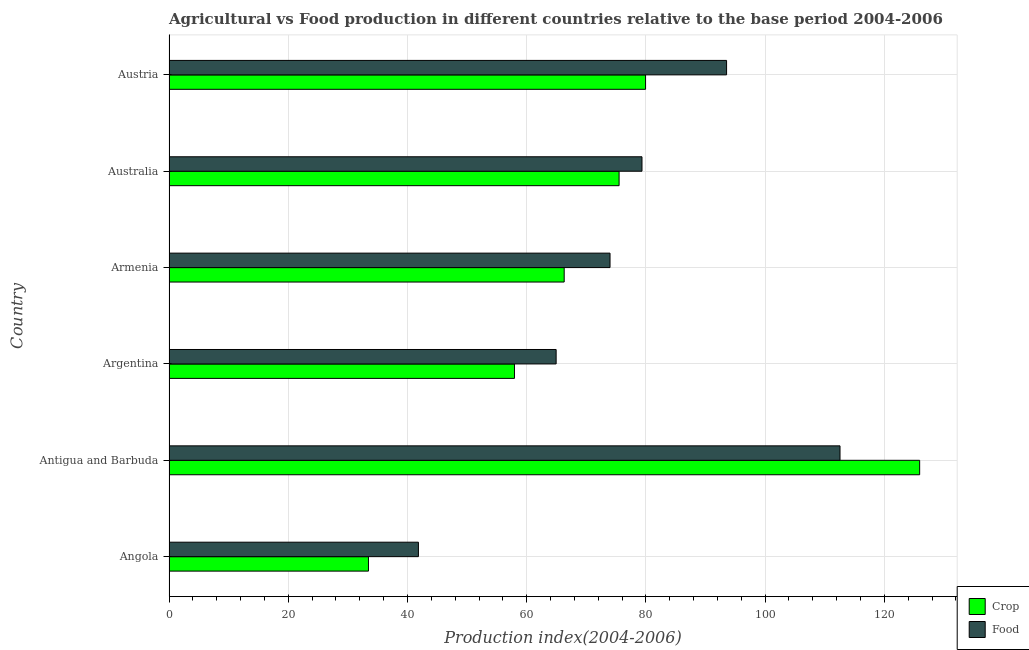Are the number of bars per tick equal to the number of legend labels?
Make the answer very short. Yes. Are the number of bars on each tick of the Y-axis equal?
Give a very brief answer. Yes. What is the label of the 6th group of bars from the top?
Provide a succinct answer. Angola. In how many cases, is the number of bars for a given country not equal to the number of legend labels?
Offer a very short reply. 0. What is the food production index in Austria?
Provide a short and direct response. 93.53. Across all countries, what is the maximum crop production index?
Provide a succinct answer. 125.92. Across all countries, what is the minimum food production index?
Provide a short and direct response. 41.84. In which country was the crop production index maximum?
Keep it short and to the point. Antigua and Barbuda. In which country was the crop production index minimum?
Provide a succinct answer. Angola. What is the total food production index in the graph?
Keep it short and to the point. 466.19. What is the difference between the crop production index in Angola and that in Argentina?
Keep it short and to the point. -24.49. What is the difference between the crop production index in Argentina and the food production index in Armenia?
Give a very brief answer. -16.03. What is the average crop production index per country?
Make the answer very short. 73.18. What is the difference between the crop production index and food production index in Armenia?
Make the answer very short. -7.69. What is the ratio of the food production index in Antigua and Barbuda to that in Austria?
Your answer should be very brief. 1.2. Is the food production index in Armenia less than that in Austria?
Keep it short and to the point. Yes. What is the difference between the highest and the second highest food production index?
Offer a very short reply. 19.03. What is the difference between the highest and the lowest crop production index?
Ensure brevity in your answer.  92.46. In how many countries, is the food production index greater than the average food production index taken over all countries?
Keep it short and to the point. 3. Is the sum of the crop production index in Argentina and Armenia greater than the maximum food production index across all countries?
Offer a terse response. Yes. What does the 2nd bar from the top in Australia represents?
Provide a succinct answer. Crop. What does the 1st bar from the bottom in Argentina represents?
Ensure brevity in your answer.  Crop. Are all the bars in the graph horizontal?
Your answer should be compact. Yes. What is the difference between two consecutive major ticks on the X-axis?
Make the answer very short. 20. Where does the legend appear in the graph?
Your answer should be compact. Bottom right. What is the title of the graph?
Offer a very short reply. Agricultural vs Food production in different countries relative to the base period 2004-2006. What is the label or title of the X-axis?
Your answer should be compact. Production index(2004-2006). What is the label or title of the Y-axis?
Offer a very short reply. Country. What is the Production index(2004-2006) of Crop in Angola?
Your answer should be very brief. 33.46. What is the Production index(2004-2006) in Food in Angola?
Ensure brevity in your answer.  41.84. What is the Production index(2004-2006) in Crop in Antigua and Barbuda?
Your response must be concise. 125.92. What is the Production index(2004-2006) of Food in Antigua and Barbuda?
Offer a very short reply. 112.56. What is the Production index(2004-2006) in Crop in Argentina?
Offer a very short reply. 57.95. What is the Production index(2004-2006) in Food in Argentina?
Offer a very short reply. 64.94. What is the Production index(2004-2006) of Crop in Armenia?
Your answer should be very brief. 66.29. What is the Production index(2004-2006) in Food in Armenia?
Your response must be concise. 73.98. What is the Production index(2004-2006) in Crop in Australia?
Make the answer very short. 75.5. What is the Production index(2004-2006) of Food in Australia?
Ensure brevity in your answer.  79.34. What is the Production index(2004-2006) of Crop in Austria?
Your answer should be compact. 79.94. What is the Production index(2004-2006) in Food in Austria?
Provide a short and direct response. 93.53. Across all countries, what is the maximum Production index(2004-2006) of Crop?
Your answer should be compact. 125.92. Across all countries, what is the maximum Production index(2004-2006) of Food?
Keep it short and to the point. 112.56. Across all countries, what is the minimum Production index(2004-2006) in Crop?
Keep it short and to the point. 33.46. Across all countries, what is the minimum Production index(2004-2006) of Food?
Your response must be concise. 41.84. What is the total Production index(2004-2006) of Crop in the graph?
Your response must be concise. 439.06. What is the total Production index(2004-2006) of Food in the graph?
Keep it short and to the point. 466.19. What is the difference between the Production index(2004-2006) of Crop in Angola and that in Antigua and Barbuda?
Give a very brief answer. -92.46. What is the difference between the Production index(2004-2006) in Food in Angola and that in Antigua and Barbuda?
Give a very brief answer. -70.72. What is the difference between the Production index(2004-2006) of Crop in Angola and that in Argentina?
Your response must be concise. -24.49. What is the difference between the Production index(2004-2006) in Food in Angola and that in Argentina?
Give a very brief answer. -23.1. What is the difference between the Production index(2004-2006) in Crop in Angola and that in Armenia?
Your response must be concise. -32.83. What is the difference between the Production index(2004-2006) in Food in Angola and that in Armenia?
Offer a very short reply. -32.14. What is the difference between the Production index(2004-2006) of Crop in Angola and that in Australia?
Your answer should be very brief. -42.04. What is the difference between the Production index(2004-2006) of Food in Angola and that in Australia?
Your response must be concise. -37.5. What is the difference between the Production index(2004-2006) of Crop in Angola and that in Austria?
Keep it short and to the point. -46.48. What is the difference between the Production index(2004-2006) in Food in Angola and that in Austria?
Make the answer very short. -51.69. What is the difference between the Production index(2004-2006) of Crop in Antigua and Barbuda and that in Argentina?
Offer a terse response. 67.97. What is the difference between the Production index(2004-2006) of Food in Antigua and Barbuda and that in Argentina?
Give a very brief answer. 47.62. What is the difference between the Production index(2004-2006) of Crop in Antigua and Barbuda and that in Armenia?
Make the answer very short. 59.63. What is the difference between the Production index(2004-2006) in Food in Antigua and Barbuda and that in Armenia?
Ensure brevity in your answer.  38.58. What is the difference between the Production index(2004-2006) of Crop in Antigua and Barbuda and that in Australia?
Make the answer very short. 50.42. What is the difference between the Production index(2004-2006) in Food in Antigua and Barbuda and that in Australia?
Your answer should be compact. 33.22. What is the difference between the Production index(2004-2006) in Crop in Antigua and Barbuda and that in Austria?
Your response must be concise. 45.98. What is the difference between the Production index(2004-2006) of Food in Antigua and Barbuda and that in Austria?
Offer a terse response. 19.03. What is the difference between the Production index(2004-2006) of Crop in Argentina and that in Armenia?
Keep it short and to the point. -8.34. What is the difference between the Production index(2004-2006) in Food in Argentina and that in Armenia?
Keep it short and to the point. -9.04. What is the difference between the Production index(2004-2006) in Crop in Argentina and that in Australia?
Offer a terse response. -17.55. What is the difference between the Production index(2004-2006) of Food in Argentina and that in Australia?
Keep it short and to the point. -14.4. What is the difference between the Production index(2004-2006) in Crop in Argentina and that in Austria?
Your answer should be very brief. -21.99. What is the difference between the Production index(2004-2006) in Food in Argentina and that in Austria?
Provide a short and direct response. -28.59. What is the difference between the Production index(2004-2006) of Crop in Armenia and that in Australia?
Your answer should be compact. -9.21. What is the difference between the Production index(2004-2006) of Food in Armenia and that in Australia?
Offer a terse response. -5.36. What is the difference between the Production index(2004-2006) in Crop in Armenia and that in Austria?
Offer a very short reply. -13.65. What is the difference between the Production index(2004-2006) of Food in Armenia and that in Austria?
Your answer should be very brief. -19.55. What is the difference between the Production index(2004-2006) of Crop in Australia and that in Austria?
Give a very brief answer. -4.44. What is the difference between the Production index(2004-2006) of Food in Australia and that in Austria?
Offer a very short reply. -14.19. What is the difference between the Production index(2004-2006) in Crop in Angola and the Production index(2004-2006) in Food in Antigua and Barbuda?
Make the answer very short. -79.1. What is the difference between the Production index(2004-2006) of Crop in Angola and the Production index(2004-2006) of Food in Argentina?
Your answer should be compact. -31.48. What is the difference between the Production index(2004-2006) of Crop in Angola and the Production index(2004-2006) of Food in Armenia?
Your answer should be compact. -40.52. What is the difference between the Production index(2004-2006) of Crop in Angola and the Production index(2004-2006) of Food in Australia?
Make the answer very short. -45.88. What is the difference between the Production index(2004-2006) in Crop in Angola and the Production index(2004-2006) in Food in Austria?
Your answer should be compact. -60.07. What is the difference between the Production index(2004-2006) in Crop in Antigua and Barbuda and the Production index(2004-2006) in Food in Argentina?
Ensure brevity in your answer.  60.98. What is the difference between the Production index(2004-2006) of Crop in Antigua and Barbuda and the Production index(2004-2006) of Food in Armenia?
Keep it short and to the point. 51.94. What is the difference between the Production index(2004-2006) in Crop in Antigua and Barbuda and the Production index(2004-2006) in Food in Australia?
Keep it short and to the point. 46.58. What is the difference between the Production index(2004-2006) of Crop in Antigua and Barbuda and the Production index(2004-2006) of Food in Austria?
Keep it short and to the point. 32.39. What is the difference between the Production index(2004-2006) in Crop in Argentina and the Production index(2004-2006) in Food in Armenia?
Ensure brevity in your answer.  -16.03. What is the difference between the Production index(2004-2006) of Crop in Argentina and the Production index(2004-2006) of Food in Australia?
Make the answer very short. -21.39. What is the difference between the Production index(2004-2006) in Crop in Argentina and the Production index(2004-2006) in Food in Austria?
Provide a short and direct response. -35.58. What is the difference between the Production index(2004-2006) of Crop in Armenia and the Production index(2004-2006) of Food in Australia?
Ensure brevity in your answer.  -13.05. What is the difference between the Production index(2004-2006) of Crop in Armenia and the Production index(2004-2006) of Food in Austria?
Your response must be concise. -27.24. What is the difference between the Production index(2004-2006) in Crop in Australia and the Production index(2004-2006) in Food in Austria?
Your answer should be compact. -18.03. What is the average Production index(2004-2006) of Crop per country?
Your answer should be very brief. 73.18. What is the average Production index(2004-2006) of Food per country?
Make the answer very short. 77.7. What is the difference between the Production index(2004-2006) of Crop and Production index(2004-2006) of Food in Angola?
Give a very brief answer. -8.38. What is the difference between the Production index(2004-2006) of Crop and Production index(2004-2006) of Food in Antigua and Barbuda?
Offer a very short reply. 13.36. What is the difference between the Production index(2004-2006) of Crop and Production index(2004-2006) of Food in Argentina?
Give a very brief answer. -6.99. What is the difference between the Production index(2004-2006) in Crop and Production index(2004-2006) in Food in Armenia?
Give a very brief answer. -7.69. What is the difference between the Production index(2004-2006) of Crop and Production index(2004-2006) of Food in Australia?
Your answer should be compact. -3.84. What is the difference between the Production index(2004-2006) of Crop and Production index(2004-2006) of Food in Austria?
Offer a very short reply. -13.59. What is the ratio of the Production index(2004-2006) of Crop in Angola to that in Antigua and Barbuda?
Provide a short and direct response. 0.27. What is the ratio of the Production index(2004-2006) of Food in Angola to that in Antigua and Barbuda?
Make the answer very short. 0.37. What is the ratio of the Production index(2004-2006) in Crop in Angola to that in Argentina?
Give a very brief answer. 0.58. What is the ratio of the Production index(2004-2006) in Food in Angola to that in Argentina?
Offer a very short reply. 0.64. What is the ratio of the Production index(2004-2006) of Crop in Angola to that in Armenia?
Offer a very short reply. 0.5. What is the ratio of the Production index(2004-2006) in Food in Angola to that in Armenia?
Your response must be concise. 0.57. What is the ratio of the Production index(2004-2006) in Crop in Angola to that in Australia?
Offer a terse response. 0.44. What is the ratio of the Production index(2004-2006) in Food in Angola to that in Australia?
Provide a short and direct response. 0.53. What is the ratio of the Production index(2004-2006) of Crop in Angola to that in Austria?
Provide a succinct answer. 0.42. What is the ratio of the Production index(2004-2006) of Food in Angola to that in Austria?
Your answer should be compact. 0.45. What is the ratio of the Production index(2004-2006) in Crop in Antigua and Barbuda to that in Argentina?
Your response must be concise. 2.17. What is the ratio of the Production index(2004-2006) in Food in Antigua and Barbuda to that in Argentina?
Offer a very short reply. 1.73. What is the ratio of the Production index(2004-2006) in Crop in Antigua and Barbuda to that in Armenia?
Your answer should be compact. 1.9. What is the ratio of the Production index(2004-2006) in Food in Antigua and Barbuda to that in Armenia?
Provide a short and direct response. 1.52. What is the ratio of the Production index(2004-2006) of Crop in Antigua and Barbuda to that in Australia?
Ensure brevity in your answer.  1.67. What is the ratio of the Production index(2004-2006) in Food in Antigua and Barbuda to that in Australia?
Provide a short and direct response. 1.42. What is the ratio of the Production index(2004-2006) in Crop in Antigua and Barbuda to that in Austria?
Offer a very short reply. 1.58. What is the ratio of the Production index(2004-2006) in Food in Antigua and Barbuda to that in Austria?
Your answer should be compact. 1.2. What is the ratio of the Production index(2004-2006) of Crop in Argentina to that in Armenia?
Your answer should be very brief. 0.87. What is the ratio of the Production index(2004-2006) of Food in Argentina to that in Armenia?
Ensure brevity in your answer.  0.88. What is the ratio of the Production index(2004-2006) of Crop in Argentina to that in Australia?
Give a very brief answer. 0.77. What is the ratio of the Production index(2004-2006) in Food in Argentina to that in Australia?
Make the answer very short. 0.82. What is the ratio of the Production index(2004-2006) in Crop in Argentina to that in Austria?
Provide a short and direct response. 0.72. What is the ratio of the Production index(2004-2006) in Food in Argentina to that in Austria?
Give a very brief answer. 0.69. What is the ratio of the Production index(2004-2006) of Crop in Armenia to that in Australia?
Ensure brevity in your answer.  0.88. What is the ratio of the Production index(2004-2006) in Food in Armenia to that in Australia?
Keep it short and to the point. 0.93. What is the ratio of the Production index(2004-2006) in Crop in Armenia to that in Austria?
Ensure brevity in your answer.  0.83. What is the ratio of the Production index(2004-2006) in Food in Armenia to that in Austria?
Provide a short and direct response. 0.79. What is the ratio of the Production index(2004-2006) of Crop in Australia to that in Austria?
Give a very brief answer. 0.94. What is the ratio of the Production index(2004-2006) of Food in Australia to that in Austria?
Your answer should be very brief. 0.85. What is the difference between the highest and the second highest Production index(2004-2006) of Crop?
Ensure brevity in your answer.  45.98. What is the difference between the highest and the second highest Production index(2004-2006) of Food?
Offer a terse response. 19.03. What is the difference between the highest and the lowest Production index(2004-2006) of Crop?
Your response must be concise. 92.46. What is the difference between the highest and the lowest Production index(2004-2006) of Food?
Provide a short and direct response. 70.72. 